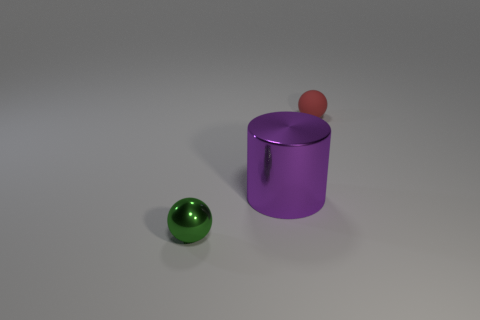Add 2 red spheres. How many objects exist? 5 Subtract all cylinders. How many objects are left? 2 Add 2 big metal cubes. How many big metal cubes exist? 2 Subtract 1 red balls. How many objects are left? 2 Subtract all red cylinders. Subtract all red cubes. How many cylinders are left? 1 Subtract all red spheres. Subtract all purple metallic cylinders. How many objects are left? 1 Add 1 purple shiny things. How many purple shiny things are left? 2 